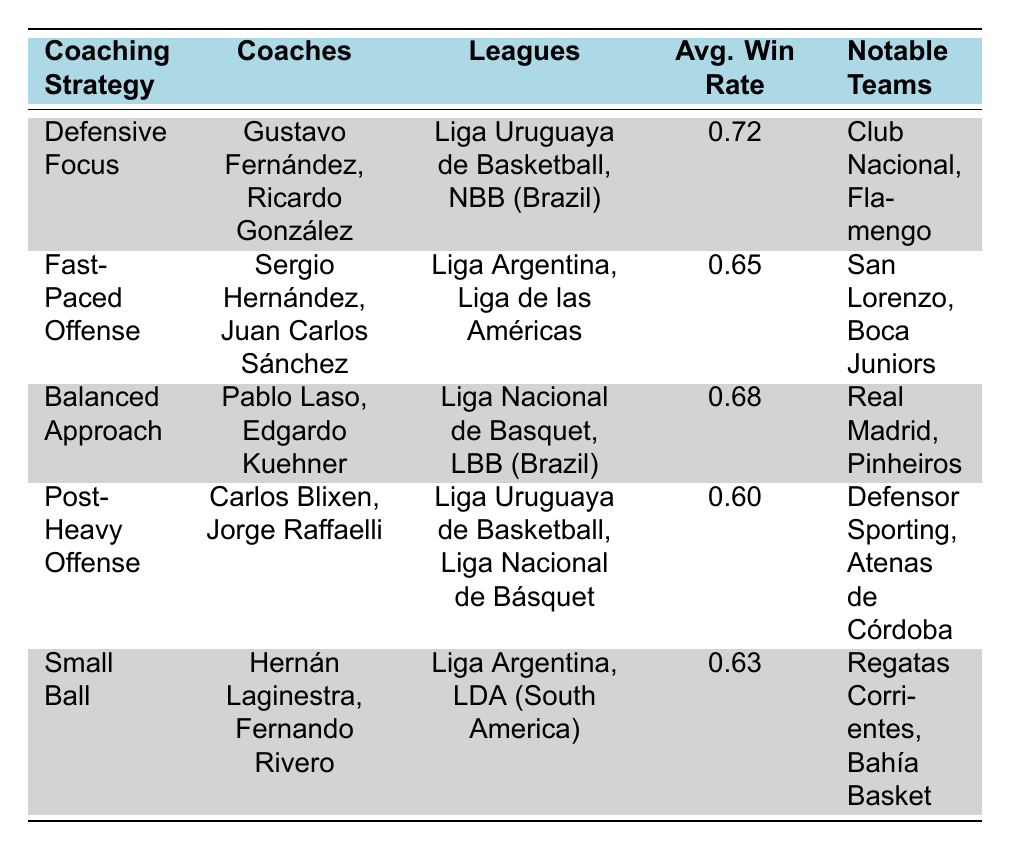What is the average win rate for the Defensive Focus strategy? The average win rate for the Defensive Focus strategy is clearly stated in the table under the "Avg. Win Rate" column for the corresponding row. The value is 0.72.
Answer: 0.72 Which coaching strategy has the highest average win rate? The table indicates that the Defensive Focus strategy has the highest average win rate at 0.72, as it is the highest value listed in the "Avg. Win Rate" column.
Answer: Defensive Focus Is the average win rate of the Post-Heavy Offense strategy lower than 0.65? The average win rate for the Post-Heavy Offense strategy is 0.60 according to the table. Since 0.60 is less than 0.65, the answer is yes.
Answer: Yes How many coaches use the Small Ball strategy? The table lists two coaches under the Small Ball strategy: Hernán Laginestra and Fernando Rivero. Therefore, there are two coaches using this strategy.
Answer: 2 What is the average win rate of the Balanced Approach strategy compared to the Fast-Paced Offense? The average win rate for the Balanced Approach is 0.68, and for the Fast-Paced Offense, it is 0.65. To compare, 0.68 - 0.65 = 0.03, which shows that the Balanced Approach has a higher win rate by 0.03.
Answer: 0.03 higher Which notable team is associated with the Fast-Paced Offense strategy? The table lists San Lorenzo and Boca Juniors under the notable teams for the Fast-Paced Offense strategy. As such, either of those two teams can be named when answering this question.
Answer: San Lorenzo (or Boca Juniors) Is Carlos Blixen coaching in the Liga Uruguaya de Basketball? According to the table, Carlos Blixen is listed as one of the coaches in the Post-Heavy Offense strategy, and he is associated with the Liga Uruguaya de Basketball. Thus, the answer is yes.
Answer: Yes Which strategy has an average win rate of exactly 0.63? Referring to the table, the strategy Small Ball displays an average win rate of 0.63, which matches the value in the "Avg. Win Rate" column for that strategy.
Answer: Small Ball What are the notable teams linked to the Balanced Approach strategy? The notable teams associated with the Balanced Approach strategy, as shown in the table, are Real Madrid and Pinheiros. This answer can be provided directly from the table without further calculation.
Answer: Real Madrid, Pinheiros 